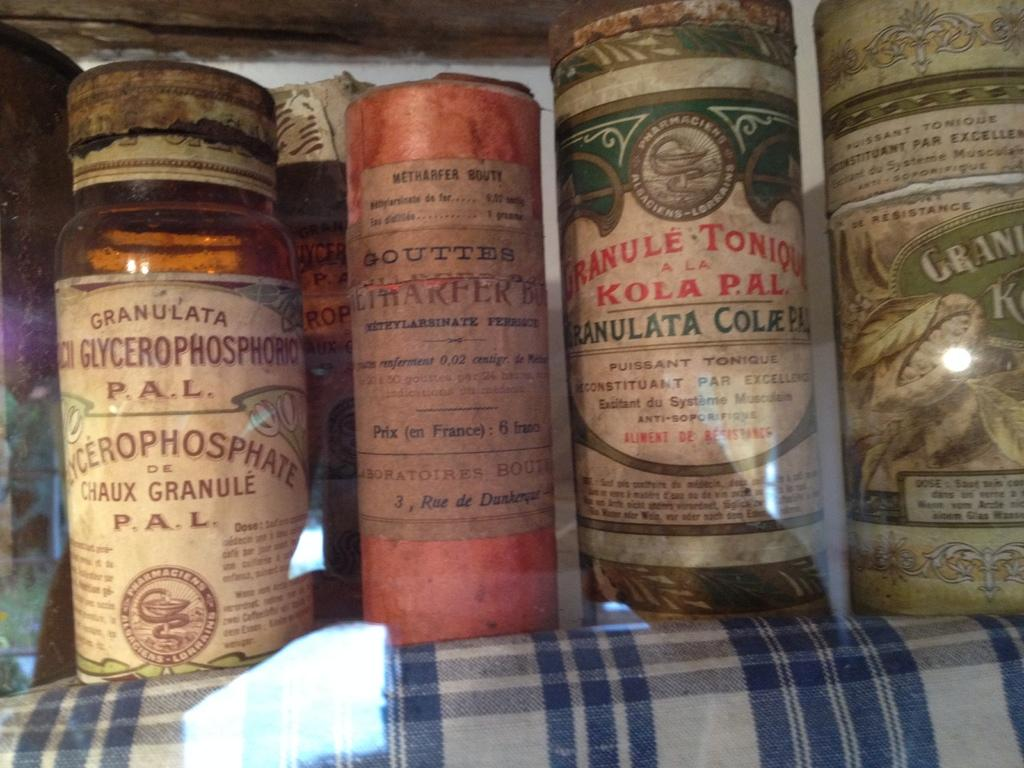<image>
Create a compact narrative representing the image presented. A very old container of glycerophosphoriq sits on a shelf with other old containers. 